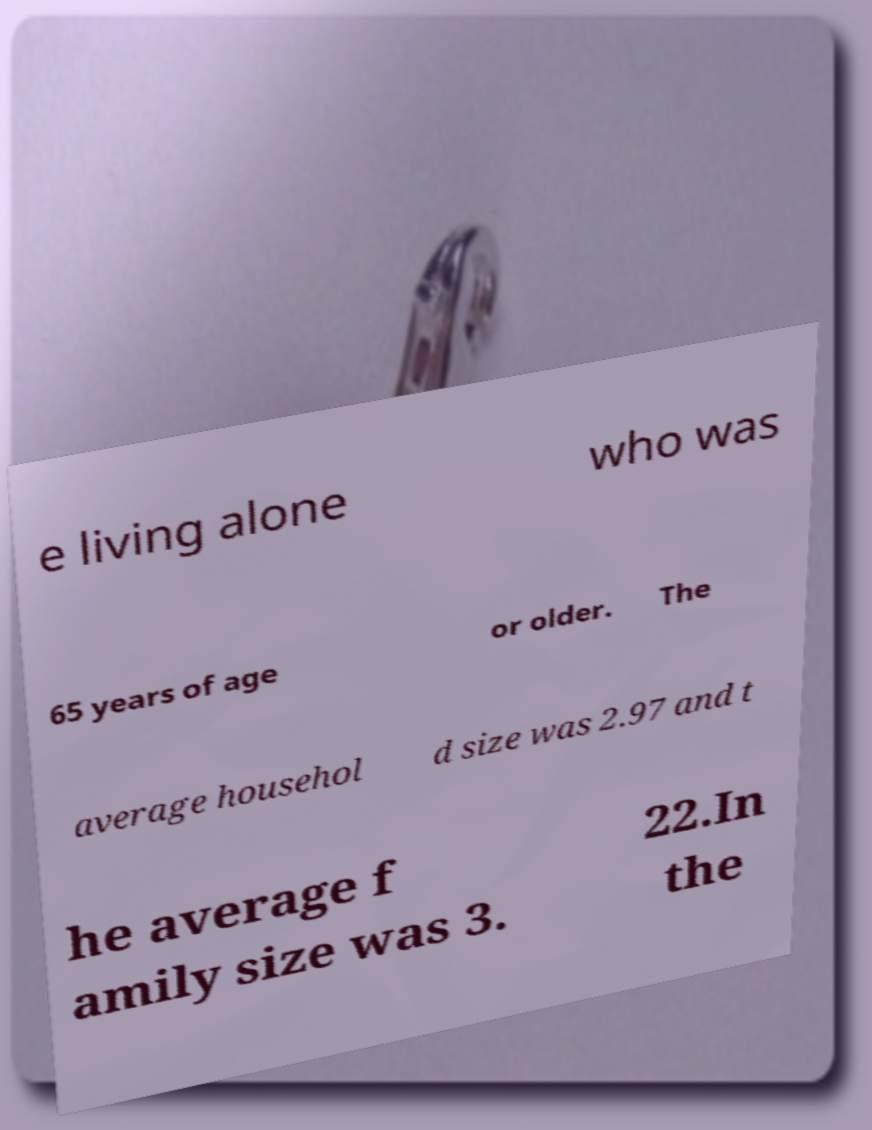Please identify and transcribe the text found in this image. e living alone who was 65 years of age or older. The average househol d size was 2.97 and t he average f amily size was 3. 22.In the 